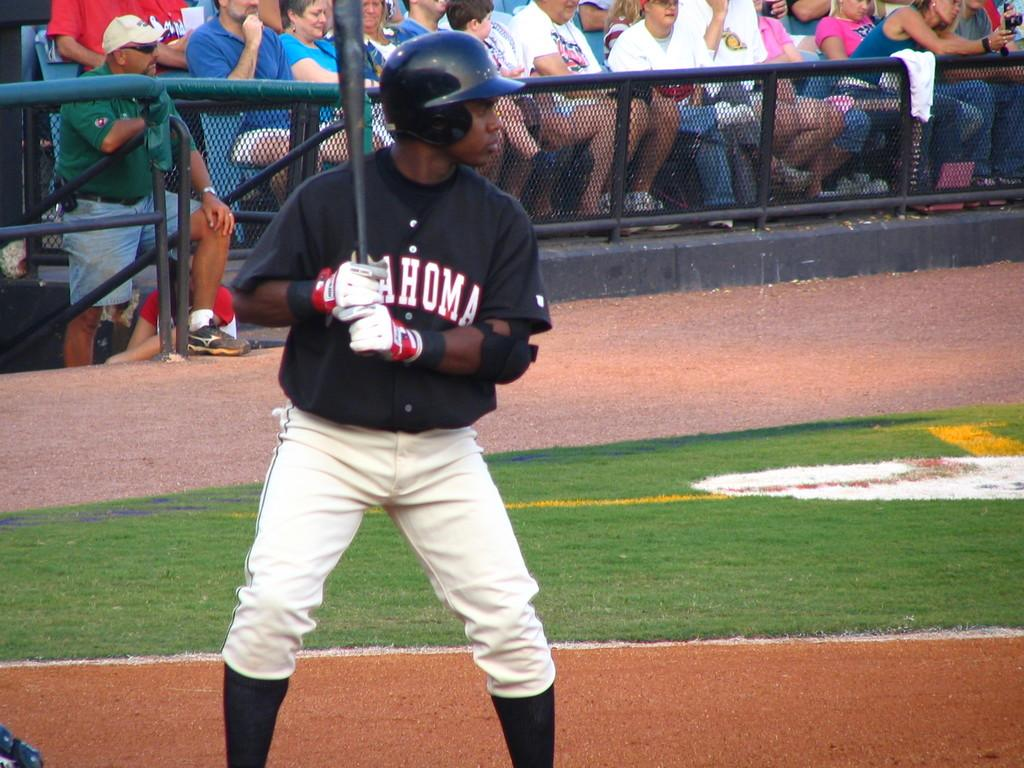Provide a one-sentence caption for the provided image. Baseball player at bat with a black jersey that has oklahoma in white letters. 